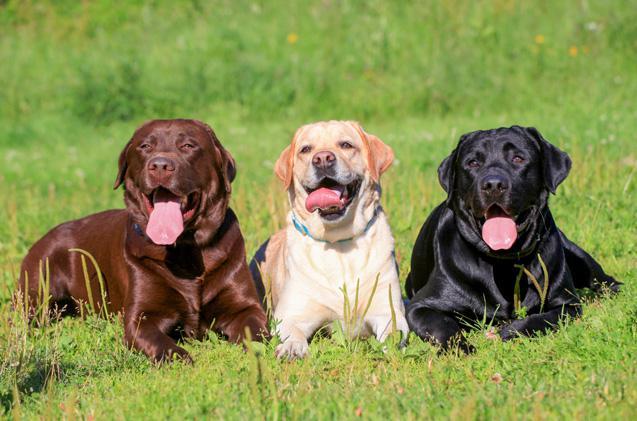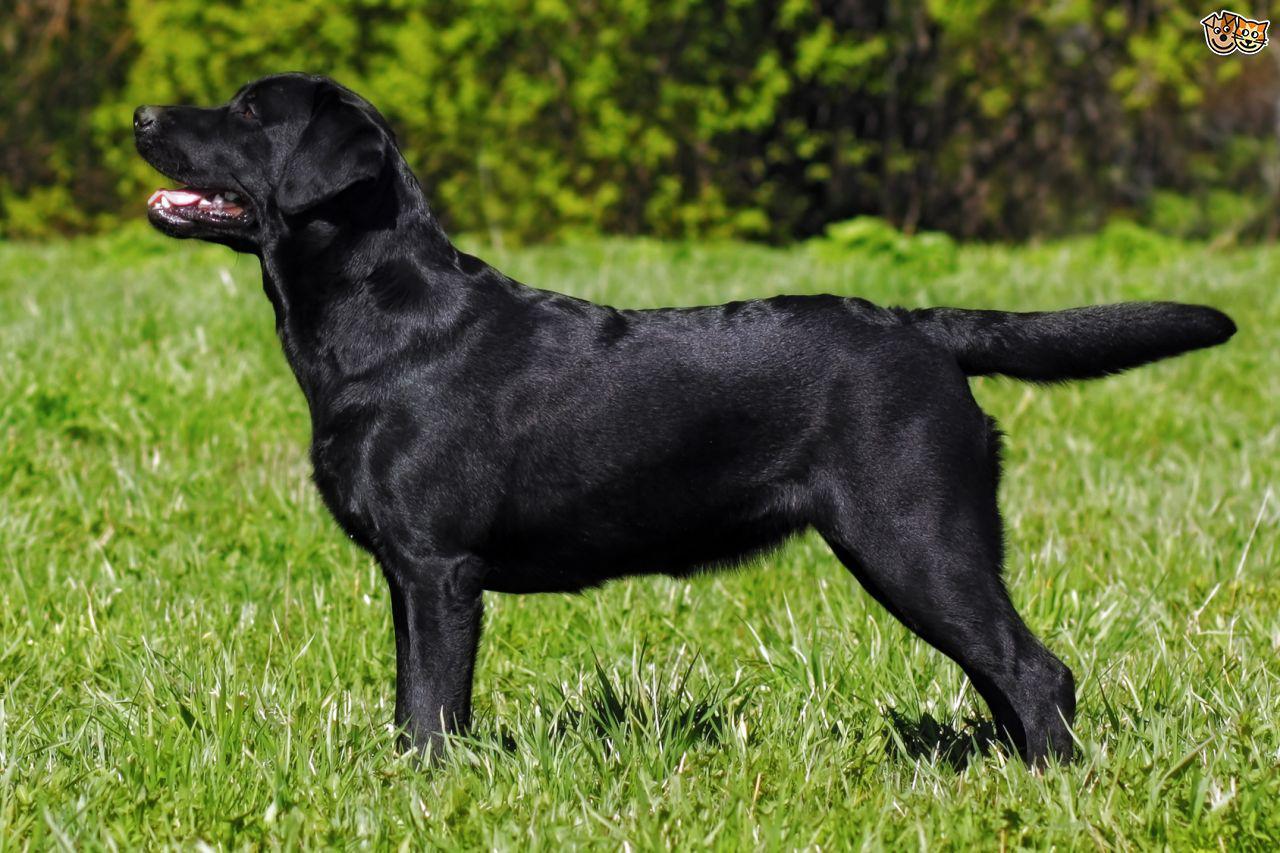The first image is the image on the left, the second image is the image on the right. Given the left and right images, does the statement "At least four dogs in a grassy area have their mouths open and their tongues showing." hold true? Answer yes or no. Yes. The first image is the image on the left, the second image is the image on the right. For the images displayed, is the sentence "There are more dogs in the left image than in the right." factually correct? Answer yes or no. Yes. 